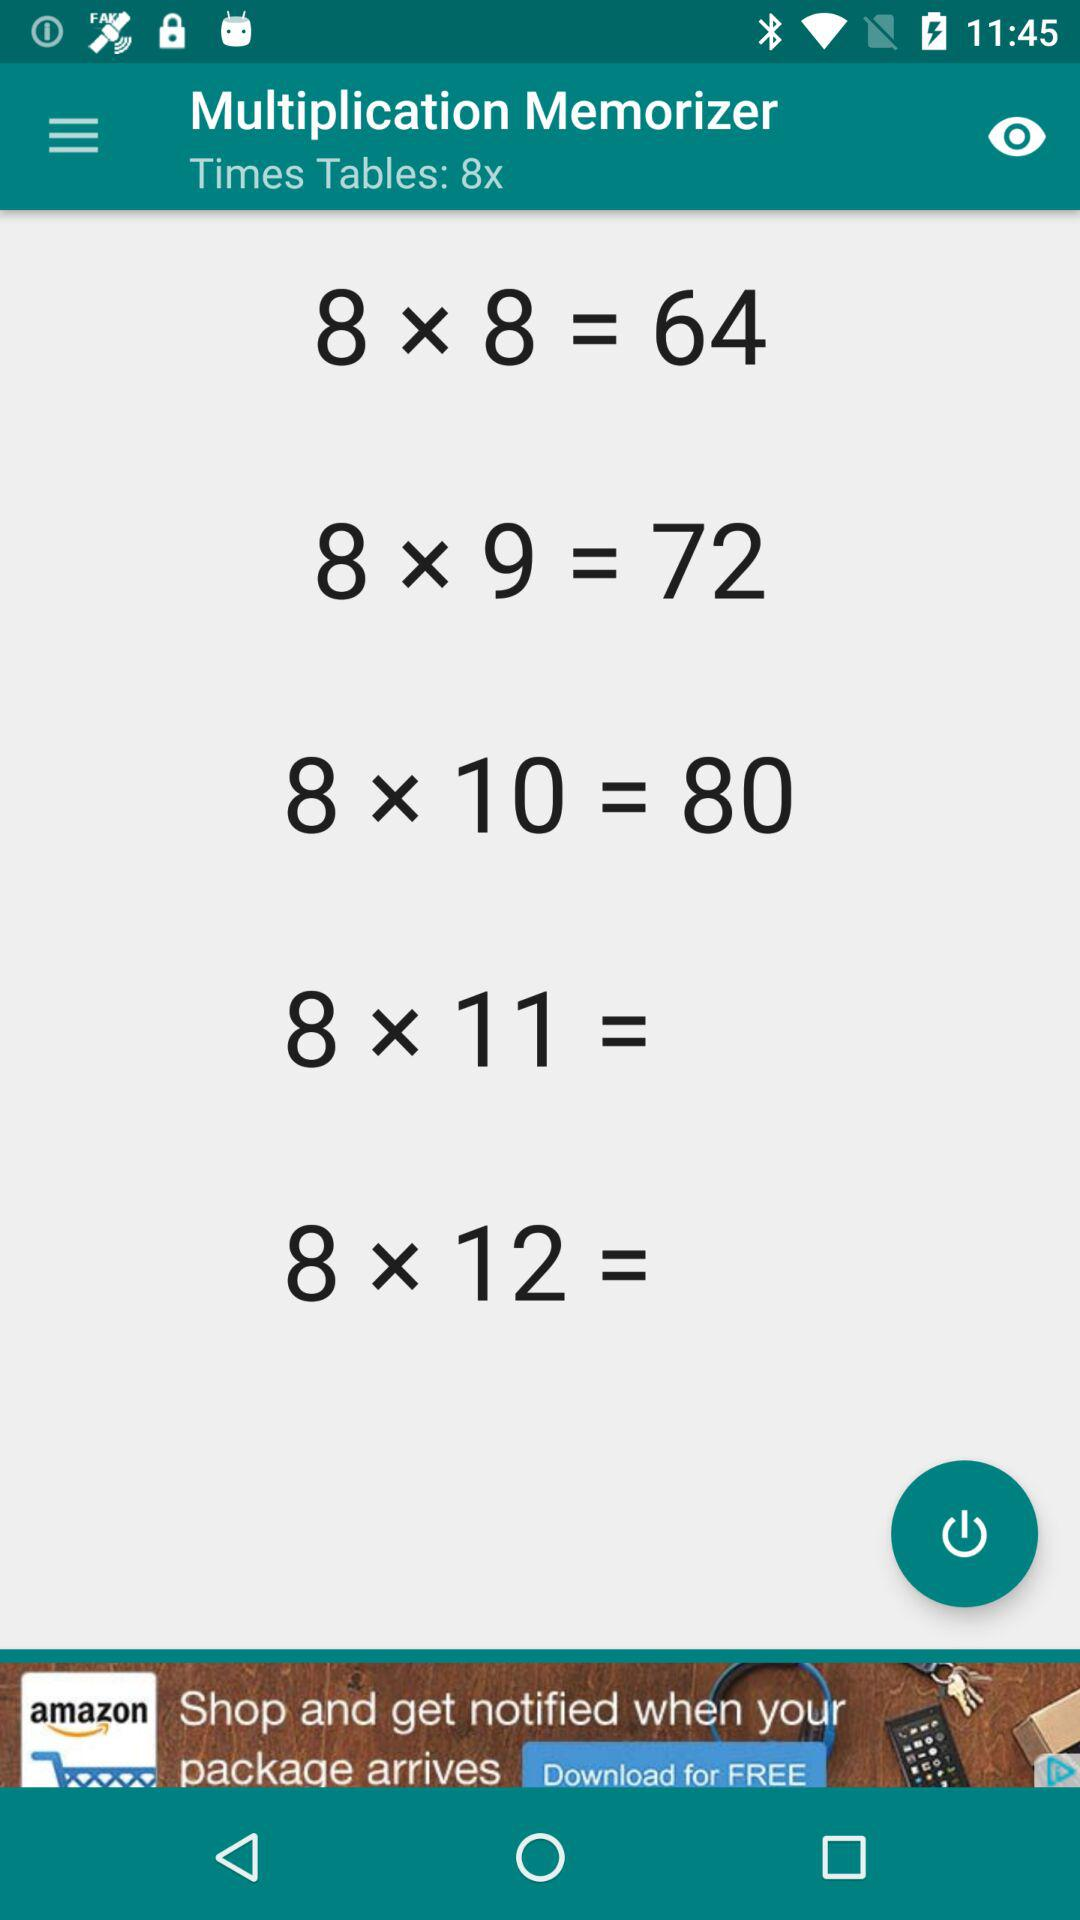What is the application name? The application name is "Multiplication Memorizer". 